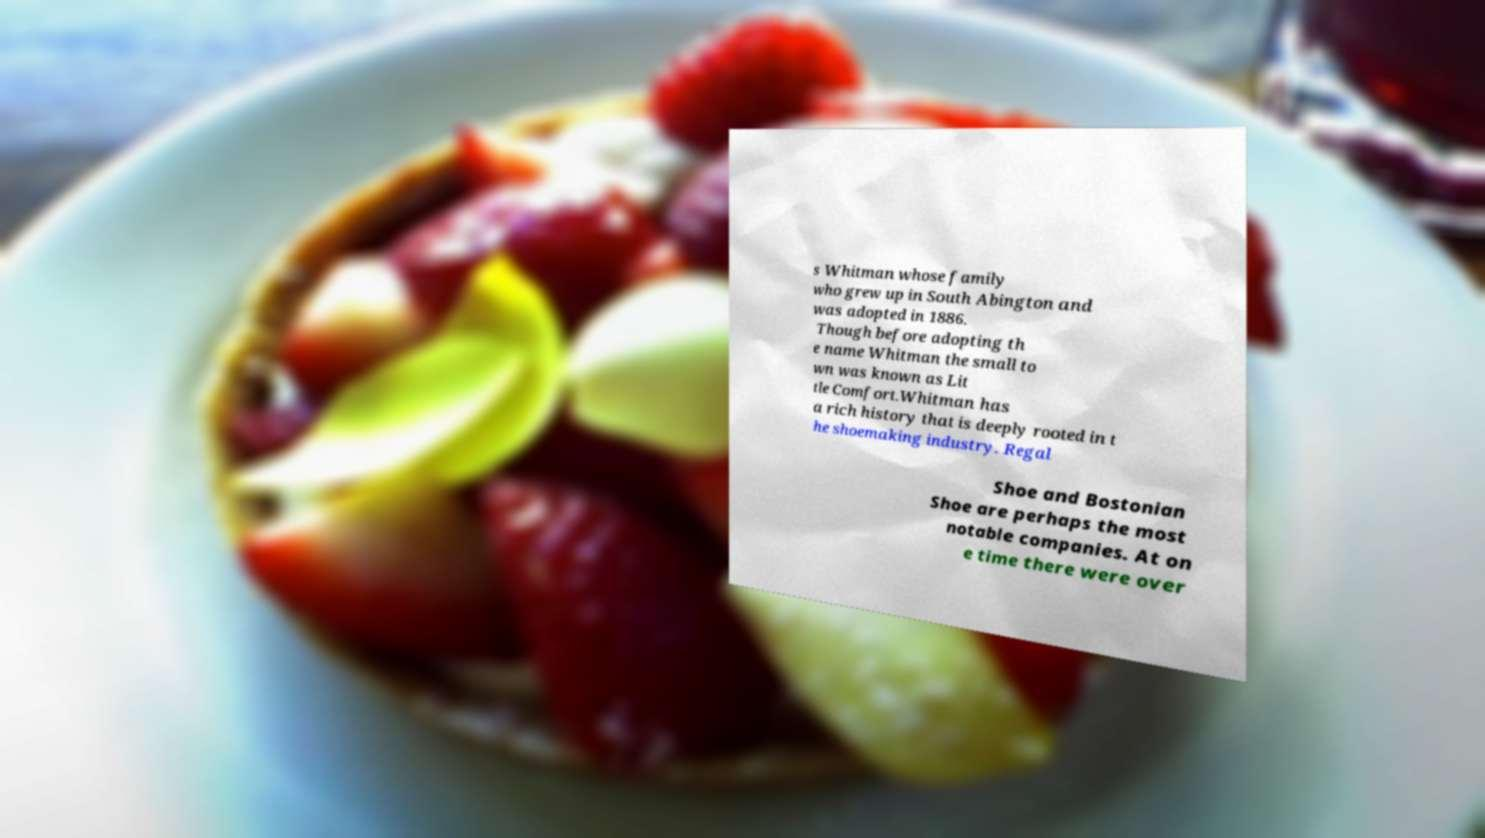I need the written content from this picture converted into text. Can you do that? s Whitman whose family who grew up in South Abington and was adopted in 1886. Though before adopting th e name Whitman the small to wn was known as Lit tle Comfort.Whitman has a rich history that is deeply rooted in t he shoemaking industry. Regal Shoe and Bostonian Shoe are perhaps the most notable companies. At on e time there were over 